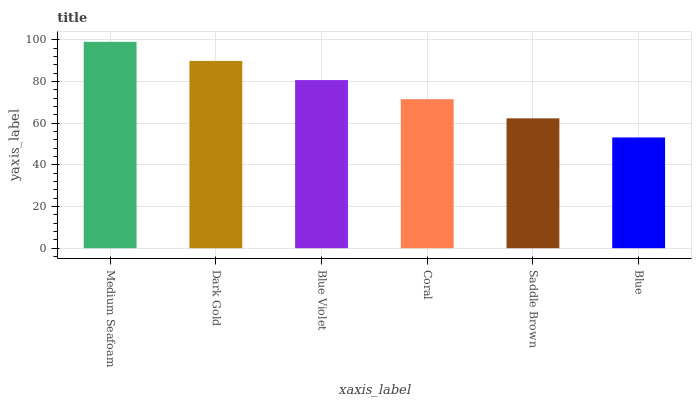Is Dark Gold the minimum?
Answer yes or no. No. Is Dark Gold the maximum?
Answer yes or no. No. Is Medium Seafoam greater than Dark Gold?
Answer yes or no. Yes. Is Dark Gold less than Medium Seafoam?
Answer yes or no. Yes. Is Dark Gold greater than Medium Seafoam?
Answer yes or no. No. Is Medium Seafoam less than Dark Gold?
Answer yes or no. No. Is Blue Violet the high median?
Answer yes or no. Yes. Is Coral the low median?
Answer yes or no. Yes. Is Medium Seafoam the high median?
Answer yes or no. No. Is Saddle Brown the low median?
Answer yes or no. No. 